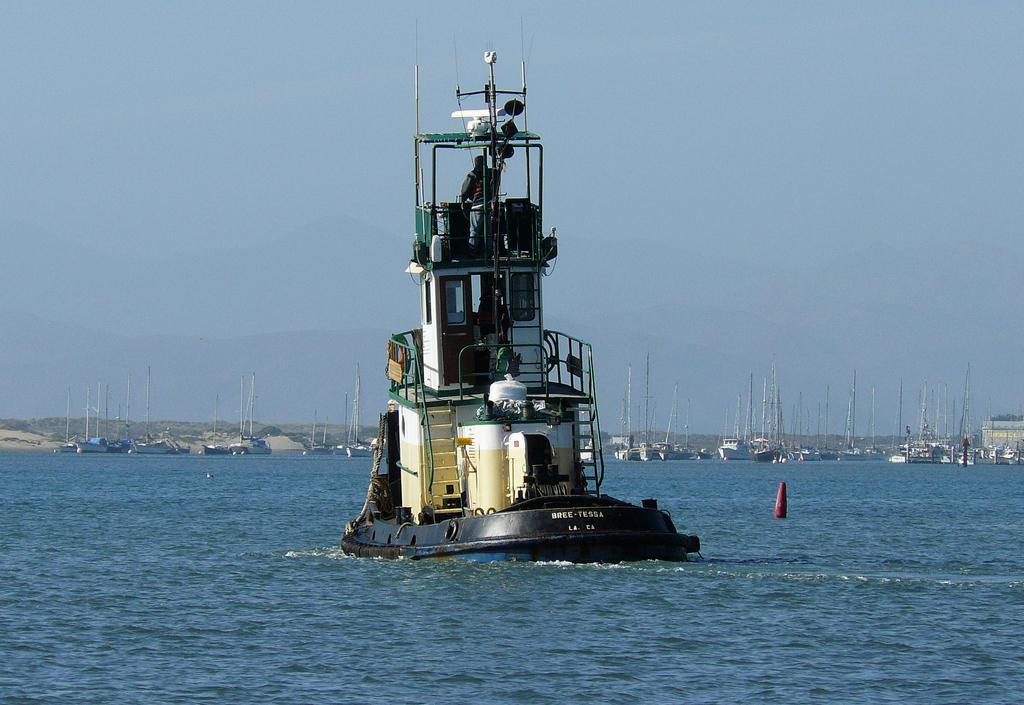What is the main subject in the center of the image? There is a person in the center of the image. What else is visible in the center of the image? There is a ship on the water in the center of the image. What can be seen in the background of the image? There are ships visible in the background, at least one building, hills, and the sky. What is the condition of the sky in the image? The sky is visible in the background, and clouds are present. What type of flesh can be seen hanging from the ship in the image? There is no flesh present in the image; it features a person, a ship on the water, and other elements in the background. 